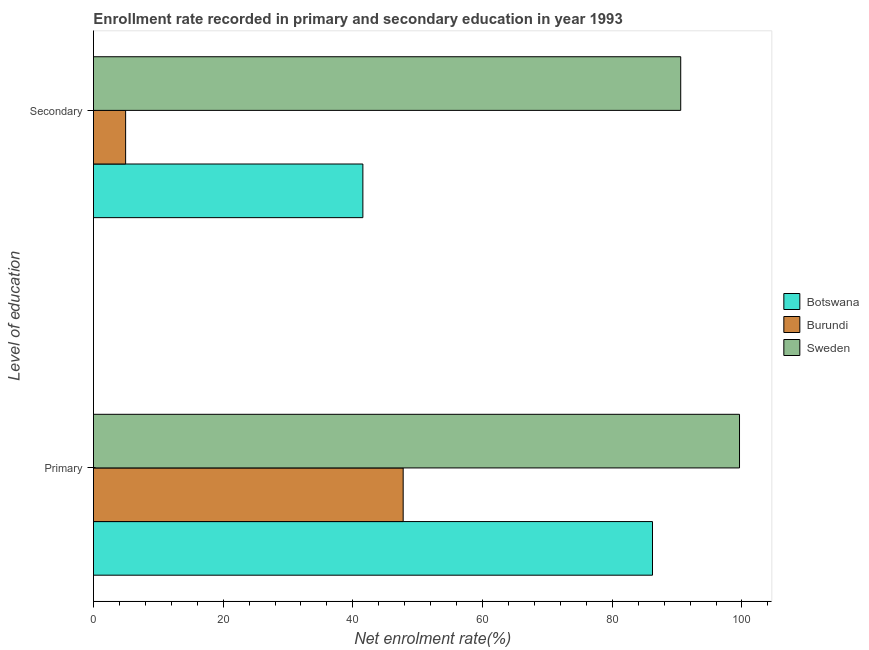How many different coloured bars are there?
Provide a short and direct response. 3. How many bars are there on the 2nd tick from the top?
Provide a succinct answer. 3. How many bars are there on the 1st tick from the bottom?
Your answer should be very brief. 3. What is the label of the 1st group of bars from the top?
Your answer should be compact. Secondary. What is the enrollment rate in primary education in Sweden?
Your response must be concise. 99.63. Across all countries, what is the maximum enrollment rate in primary education?
Make the answer very short. 99.63. Across all countries, what is the minimum enrollment rate in secondary education?
Provide a succinct answer. 4.96. In which country was the enrollment rate in secondary education maximum?
Give a very brief answer. Sweden. In which country was the enrollment rate in primary education minimum?
Provide a succinct answer. Burundi. What is the total enrollment rate in primary education in the graph?
Your response must be concise. 233.59. What is the difference between the enrollment rate in secondary education in Burundi and that in Botswana?
Your answer should be very brief. -36.59. What is the difference between the enrollment rate in primary education in Sweden and the enrollment rate in secondary education in Burundi?
Give a very brief answer. 94.67. What is the average enrollment rate in primary education per country?
Your response must be concise. 77.86. What is the difference between the enrollment rate in secondary education and enrollment rate in primary education in Botswana?
Provide a succinct answer. -44.66. What is the ratio of the enrollment rate in primary education in Burundi to that in Botswana?
Provide a short and direct response. 0.55. Is the enrollment rate in primary education in Botswana less than that in Burundi?
Provide a succinct answer. No. In how many countries, is the enrollment rate in primary education greater than the average enrollment rate in primary education taken over all countries?
Offer a terse response. 2. What does the 2nd bar from the top in Secondary represents?
Give a very brief answer. Burundi. What does the 1st bar from the bottom in Secondary represents?
Provide a succinct answer. Botswana. How many bars are there?
Your answer should be very brief. 6. Are all the bars in the graph horizontal?
Offer a terse response. Yes. How many countries are there in the graph?
Provide a short and direct response. 3. Does the graph contain any zero values?
Make the answer very short. No. Where does the legend appear in the graph?
Make the answer very short. Center right. How many legend labels are there?
Make the answer very short. 3. How are the legend labels stacked?
Your response must be concise. Vertical. What is the title of the graph?
Keep it short and to the point. Enrollment rate recorded in primary and secondary education in year 1993. What is the label or title of the X-axis?
Provide a succinct answer. Net enrolment rate(%). What is the label or title of the Y-axis?
Ensure brevity in your answer.  Level of education. What is the Net enrolment rate(%) in Botswana in Primary?
Ensure brevity in your answer.  86.21. What is the Net enrolment rate(%) in Burundi in Primary?
Provide a short and direct response. 47.76. What is the Net enrolment rate(%) of Sweden in Primary?
Provide a succinct answer. 99.63. What is the Net enrolment rate(%) of Botswana in Secondary?
Offer a terse response. 41.54. What is the Net enrolment rate(%) of Burundi in Secondary?
Offer a terse response. 4.96. What is the Net enrolment rate(%) in Sweden in Secondary?
Your answer should be compact. 90.56. Across all Level of education, what is the maximum Net enrolment rate(%) in Botswana?
Your response must be concise. 86.21. Across all Level of education, what is the maximum Net enrolment rate(%) of Burundi?
Provide a succinct answer. 47.76. Across all Level of education, what is the maximum Net enrolment rate(%) of Sweden?
Provide a succinct answer. 99.63. Across all Level of education, what is the minimum Net enrolment rate(%) of Botswana?
Provide a succinct answer. 41.54. Across all Level of education, what is the minimum Net enrolment rate(%) in Burundi?
Make the answer very short. 4.96. Across all Level of education, what is the minimum Net enrolment rate(%) in Sweden?
Offer a terse response. 90.56. What is the total Net enrolment rate(%) in Botswana in the graph?
Ensure brevity in your answer.  127.75. What is the total Net enrolment rate(%) of Burundi in the graph?
Keep it short and to the point. 52.72. What is the total Net enrolment rate(%) in Sweden in the graph?
Make the answer very short. 190.18. What is the difference between the Net enrolment rate(%) in Botswana in Primary and that in Secondary?
Make the answer very short. 44.66. What is the difference between the Net enrolment rate(%) in Burundi in Primary and that in Secondary?
Provide a succinct answer. 42.8. What is the difference between the Net enrolment rate(%) of Sweden in Primary and that in Secondary?
Keep it short and to the point. 9.07. What is the difference between the Net enrolment rate(%) in Botswana in Primary and the Net enrolment rate(%) in Burundi in Secondary?
Offer a very short reply. 81.25. What is the difference between the Net enrolment rate(%) of Botswana in Primary and the Net enrolment rate(%) of Sweden in Secondary?
Your response must be concise. -4.35. What is the difference between the Net enrolment rate(%) of Burundi in Primary and the Net enrolment rate(%) of Sweden in Secondary?
Make the answer very short. -42.8. What is the average Net enrolment rate(%) of Botswana per Level of education?
Make the answer very short. 63.88. What is the average Net enrolment rate(%) of Burundi per Level of education?
Offer a very short reply. 26.36. What is the average Net enrolment rate(%) in Sweden per Level of education?
Offer a terse response. 95.09. What is the difference between the Net enrolment rate(%) in Botswana and Net enrolment rate(%) in Burundi in Primary?
Keep it short and to the point. 38.45. What is the difference between the Net enrolment rate(%) of Botswana and Net enrolment rate(%) of Sweden in Primary?
Provide a short and direct response. -13.42. What is the difference between the Net enrolment rate(%) of Burundi and Net enrolment rate(%) of Sweden in Primary?
Provide a short and direct response. -51.87. What is the difference between the Net enrolment rate(%) of Botswana and Net enrolment rate(%) of Burundi in Secondary?
Offer a terse response. 36.59. What is the difference between the Net enrolment rate(%) of Botswana and Net enrolment rate(%) of Sweden in Secondary?
Your answer should be compact. -49.01. What is the difference between the Net enrolment rate(%) of Burundi and Net enrolment rate(%) of Sweden in Secondary?
Provide a succinct answer. -85.6. What is the ratio of the Net enrolment rate(%) of Botswana in Primary to that in Secondary?
Provide a succinct answer. 2.08. What is the ratio of the Net enrolment rate(%) in Burundi in Primary to that in Secondary?
Your response must be concise. 9.63. What is the ratio of the Net enrolment rate(%) in Sweden in Primary to that in Secondary?
Your answer should be very brief. 1.1. What is the difference between the highest and the second highest Net enrolment rate(%) in Botswana?
Keep it short and to the point. 44.66. What is the difference between the highest and the second highest Net enrolment rate(%) of Burundi?
Offer a terse response. 42.8. What is the difference between the highest and the second highest Net enrolment rate(%) of Sweden?
Ensure brevity in your answer.  9.07. What is the difference between the highest and the lowest Net enrolment rate(%) of Botswana?
Ensure brevity in your answer.  44.66. What is the difference between the highest and the lowest Net enrolment rate(%) in Burundi?
Provide a short and direct response. 42.8. What is the difference between the highest and the lowest Net enrolment rate(%) in Sweden?
Your answer should be compact. 9.07. 